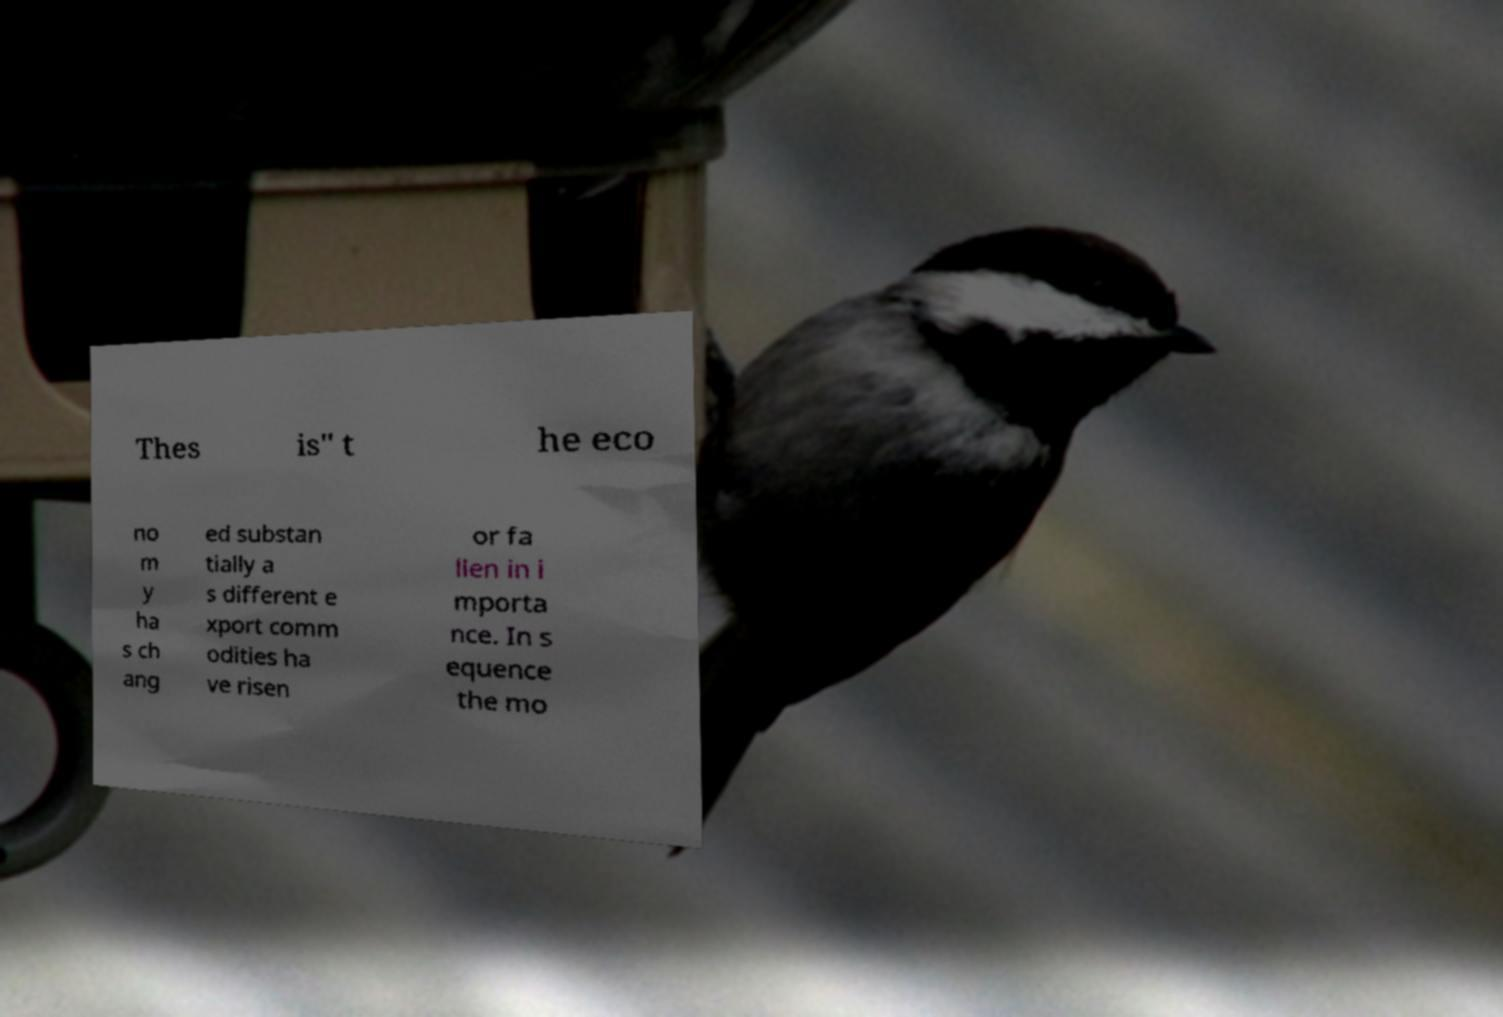Can you read and provide the text displayed in the image?This photo seems to have some interesting text. Can you extract and type it out for me? Thes is" t he eco no m y ha s ch ang ed substan tially a s different e xport comm odities ha ve risen or fa llen in i mporta nce. In s equence the mo 